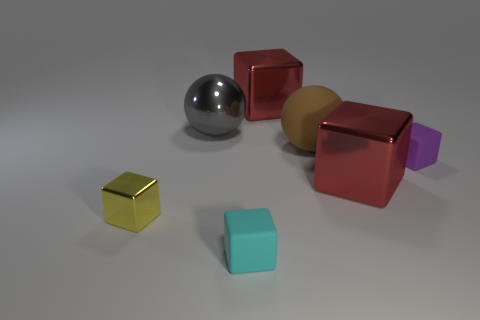Subtract 2 cubes. How many cubes are left? 3 Subtract all cyan matte blocks. How many blocks are left? 4 Subtract all purple cubes. How many cubes are left? 4 Subtract all yellow cubes. Subtract all green cylinders. How many cubes are left? 4 Add 3 tiny cyan matte objects. How many objects exist? 10 Subtract all balls. How many objects are left? 5 Add 3 large purple matte cylinders. How many large purple matte cylinders exist? 3 Subtract 0 brown blocks. How many objects are left? 7 Subtract all big brown matte things. Subtract all yellow metal things. How many objects are left? 5 Add 2 red blocks. How many red blocks are left? 4 